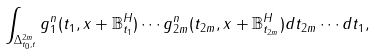<formula> <loc_0><loc_0><loc_500><loc_500>\int _ { \Delta _ { t _ { 0 } , t } ^ { 2 m } } g _ { 1 } ^ { n } ( t _ { 1 } , x + \mathbb { B } _ { t _ { 1 } } ^ { H } ) \cdots g _ { 2 m } ^ { n } ( t _ { 2 m } , x + \mathbb { B } _ { t _ { 2 m } } ^ { H } ) d t _ { 2 m } \cdots d t _ { 1 } ,</formula> 